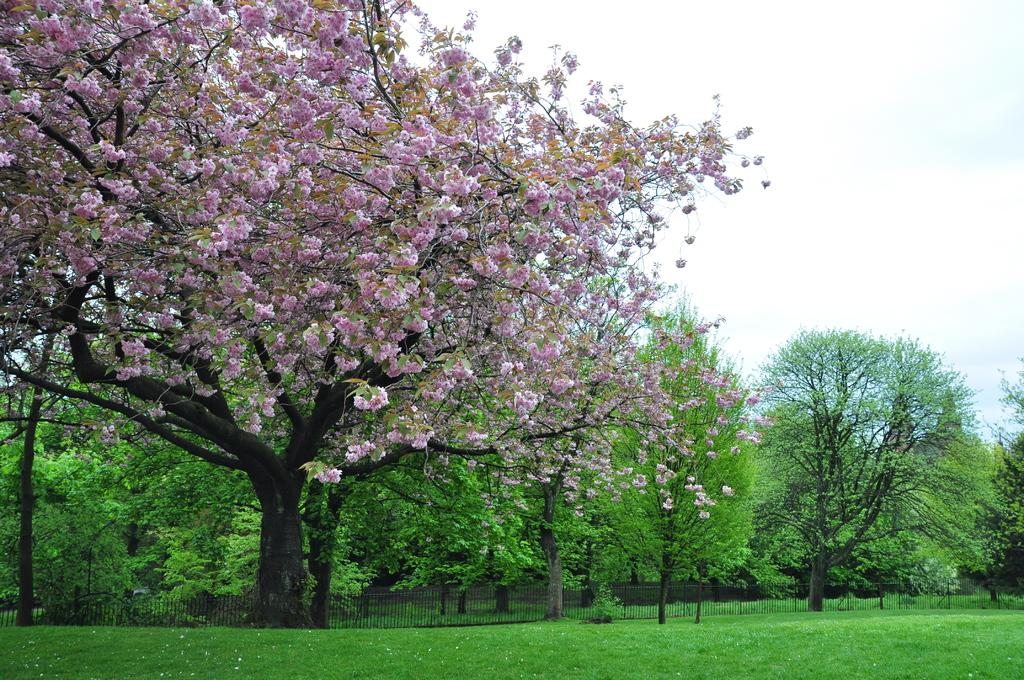What color are the flowers in the image? The flowers in the image are purple. What color is the grass in the image? The grass in the image is green. What color are the trees in the image? The trees in the image are green. What structure can be seen in the image? There is a railing in the image. What color is the sky in the image? The sky in the image is white. Can you see any waves in the image? There are no waves present in the image. What type of hope can be seen in the image? There is no representation of hope in the image; it features flowers, grass, trees, a railing, and a white sky. 